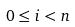Convert formula to latex. <formula><loc_0><loc_0><loc_500><loc_500>0 \leq i < n</formula> 